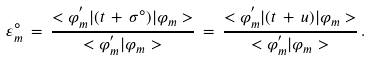<formula> <loc_0><loc_0><loc_500><loc_500>\varepsilon ^ { \circ } _ { m } \, = \, \frac { < \varphi _ { m } ^ { ^ { \prime } } | ( t \, + \, \sigma ^ { \circ } ) | \varphi _ { m } > } { < \varphi _ { m } ^ { ^ { \prime } } | \varphi _ { m } > } \, = \, \frac { < \varphi _ { m } ^ { ^ { \prime } } | ( t \, + \, u ) | \varphi _ { m } > } { < \varphi ^ { ^ { \prime } } _ { m } | \varphi _ { m } > } \, .</formula> 